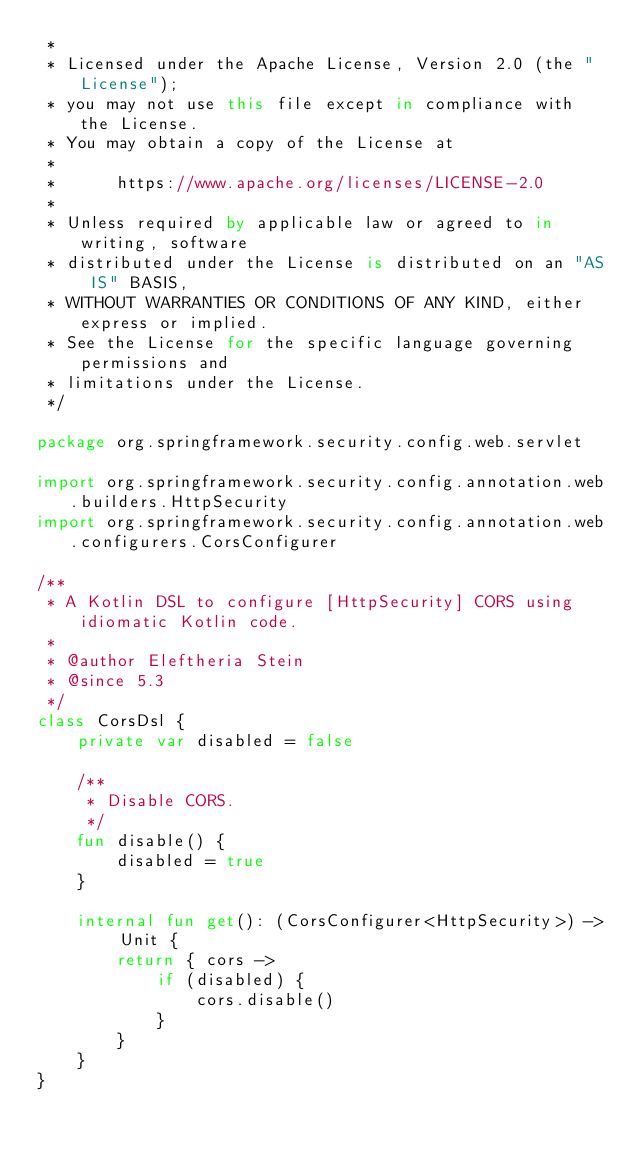Convert code to text. <code><loc_0><loc_0><loc_500><loc_500><_Kotlin_> *
 * Licensed under the Apache License, Version 2.0 (the "License");
 * you may not use this file except in compliance with the License.
 * You may obtain a copy of the License at
 *
 *      https://www.apache.org/licenses/LICENSE-2.0
 *
 * Unless required by applicable law or agreed to in writing, software
 * distributed under the License is distributed on an "AS IS" BASIS,
 * WITHOUT WARRANTIES OR CONDITIONS OF ANY KIND, either express or implied.
 * See the License for the specific language governing permissions and
 * limitations under the License.
 */

package org.springframework.security.config.web.servlet

import org.springframework.security.config.annotation.web.builders.HttpSecurity
import org.springframework.security.config.annotation.web.configurers.CorsConfigurer

/**
 * A Kotlin DSL to configure [HttpSecurity] CORS using idiomatic Kotlin code.
 *
 * @author Eleftheria Stein
 * @since 5.3
 */
class CorsDsl {
    private var disabled = false

    /**
     * Disable CORS.
     */
    fun disable() {
        disabled = true
    }

    internal fun get(): (CorsConfigurer<HttpSecurity>) -> Unit {
        return { cors ->
            if (disabled) {
                cors.disable()
            }
        }
    }
}
</code> 